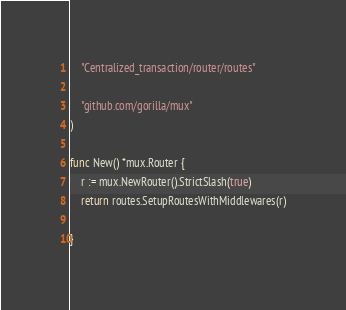Convert code to text. <code><loc_0><loc_0><loc_500><loc_500><_Go_>	"Centralized_transaction/router/routes"

	"github.com/gorilla/mux"
)

func New() *mux.Router {
	r := mux.NewRouter().StrictSlash(true)
	return routes.SetupRoutesWithMiddlewares(r)

}
</code> 